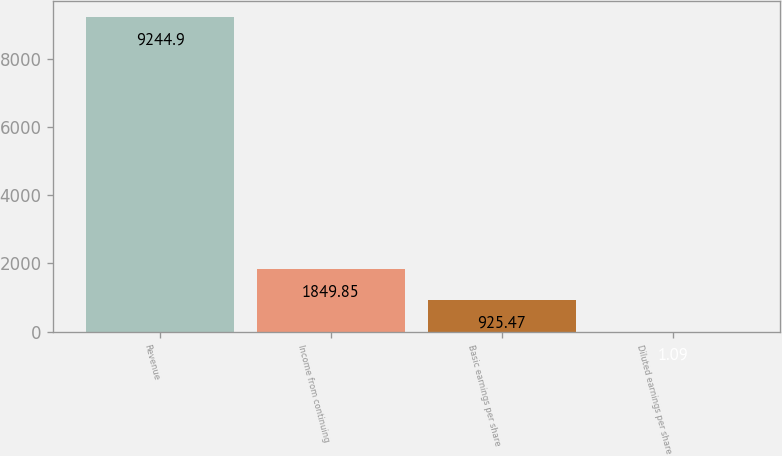Convert chart. <chart><loc_0><loc_0><loc_500><loc_500><bar_chart><fcel>Revenue<fcel>Income from continuing<fcel>Basic earnings per share<fcel>Diluted earnings per share<nl><fcel>9244.9<fcel>1849.85<fcel>925.47<fcel>1.09<nl></chart> 